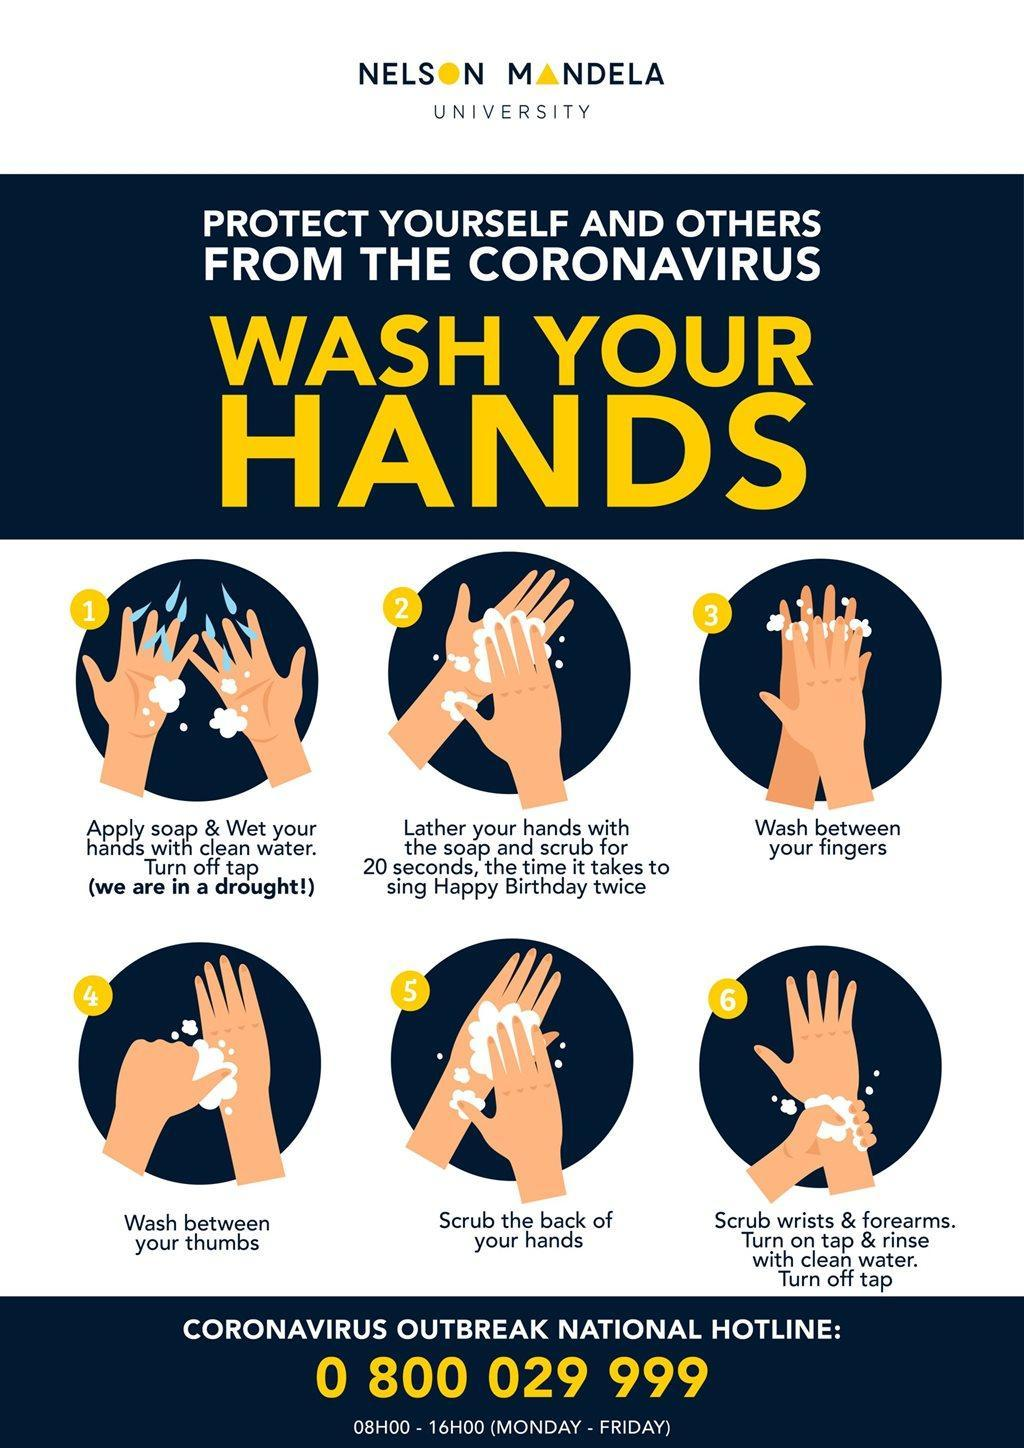What is the time takes to sing a happy birthday song twice?
Answer the question with a short phrase. 20 seconds 